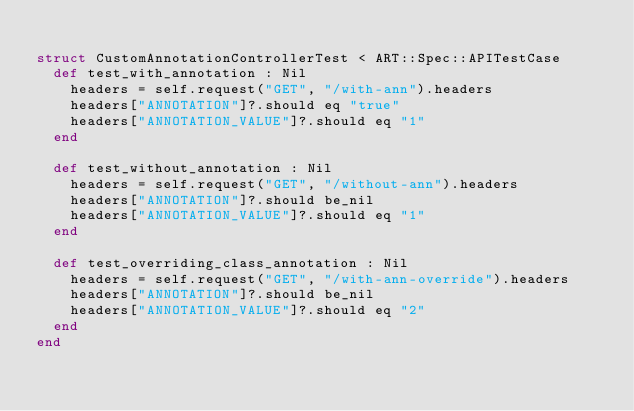<code> <loc_0><loc_0><loc_500><loc_500><_Crystal_>
struct CustomAnnotationControllerTest < ART::Spec::APITestCase
  def test_with_annotation : Nil
    headers = self.request("GET", "/with-ann").headers
    headers["ANNOTATION"]?.should eq "true"
    headers["ANNOTATION_VALUE"]?.should eq "1"
  end

  def test_without_annotation : Nil
    headers = self.request("GET", "/without-ann").headers
    headers["ANNOTATION"]?.should be_nil
    headers["ANNOTATION_VALUE"]?.should eq "1"
  end

  def test_overriding_class_annotation : Nil
    headers = self.request("GET", "/with-ann-override").headers
    headers["ANNOTATION"]?.should be_nil
    headers["ANNOTATION_VALUE"]?.should eq "2"
  end
end
</code> 